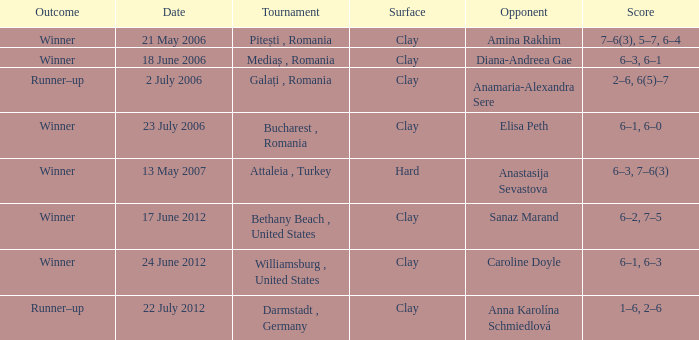Parse the table in full. {'header': ['Outcome', 'Date', 'Tournament', 'Surface', 'Opponent', 'Score'], 'rows': [['Winner', '21 May 2006', 'Pitești , Romania', 'Clay', 'Amina Rakhim', '7–6(3), 5–7, 6–4'], ['Winner', '18 June 2006', 'Mediaș , Romania', 'Clay', 'Diana-Andreea Gae', '6–3, 6–1'], ['Runner–up', '2 July 2006', 'Galați , Romania', 'Clay', 'Anamaria-Alexandra Sere', '2–6, 6(5)–7'], ['Winner', '23 July 2006', 'Bucharest , Romania', 'Clay', 'Elisa Peth', '6–1, 6–0'], ['Winner', '13 May 2007', 'Attaleia , Turkey', 'Hard', 'Anastasija Sevastova', '6–3, 7–6(3)'], ['Winner', '17 June 2012', 'Bethany Beach , United States', 'Clay', 'Sanaz Marand', '6–2, 7–5'], ['Winner', '24 June 2012', 'Williamsburg , United States', 'Clay', 'Caroline Doyle', '6–1, 6–3'], ['Runner–up', '22 July 2012', 'Darmstadt , Germany', 'Clay', 'Anna Karolína Schmiedlová', '1–6, 2–6']]} What was the outcome in the contest against sanaz marand? 6–2, 7–5. 